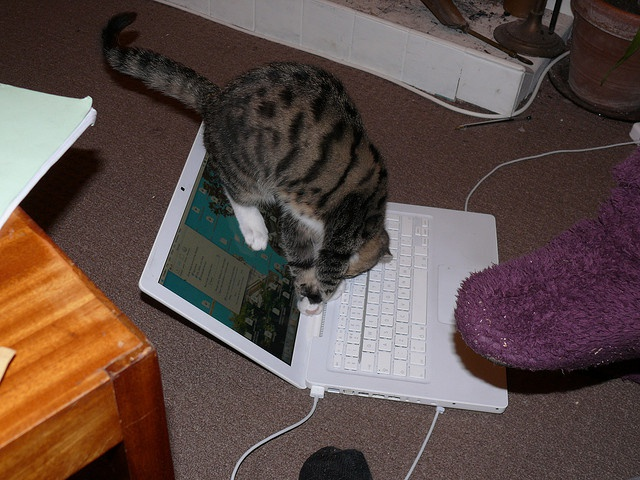Describe the objects in this image and their specific colors. I can see laptop in black, darkgray, and lightgray tones, cat in black and gray tones, dining table in black, brown, red, maroon, and orange tones, people in black and purple tones, and potted plant in black and gray tones in this image. 